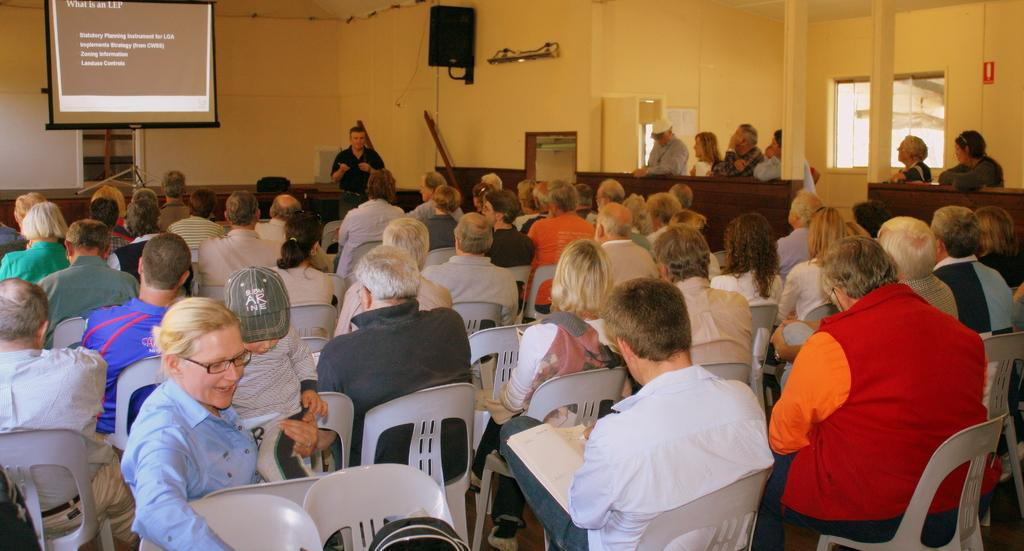What are the people in the image doing? There are people sitting on chairs and standing in the image. What can be seen on the screen in the image? The facts do not specify what is on the screen, so we cannot answer that question. What is the stand used for in the image? The facts do not specify the purpose of the stand, so we cannot answer that question. What is the speaker used for in the image? The speaker is likely used for amplifying sound or making announcements. What is written or displayed on the board in the image? The facts do not specify what is written or displayed on the board, so we cannot answer that question. What is the wall made of in the image? The facts do not specify the material of the wall, so we cannot answer that question. How many additional objects are present in the image? The facts do not specify the number of additional objects, so we cannot answer that question. Is there a pest crawling on the wall in the image? There is no mention of a pest in the image, so we cannot answer that question. What is the highest point in the image? The facts do not specify any heights or elevations in the image, so we cannot answer that question. Is it raining in the image? The facts do not mention any weather conditions, so we cannot answer that question. 